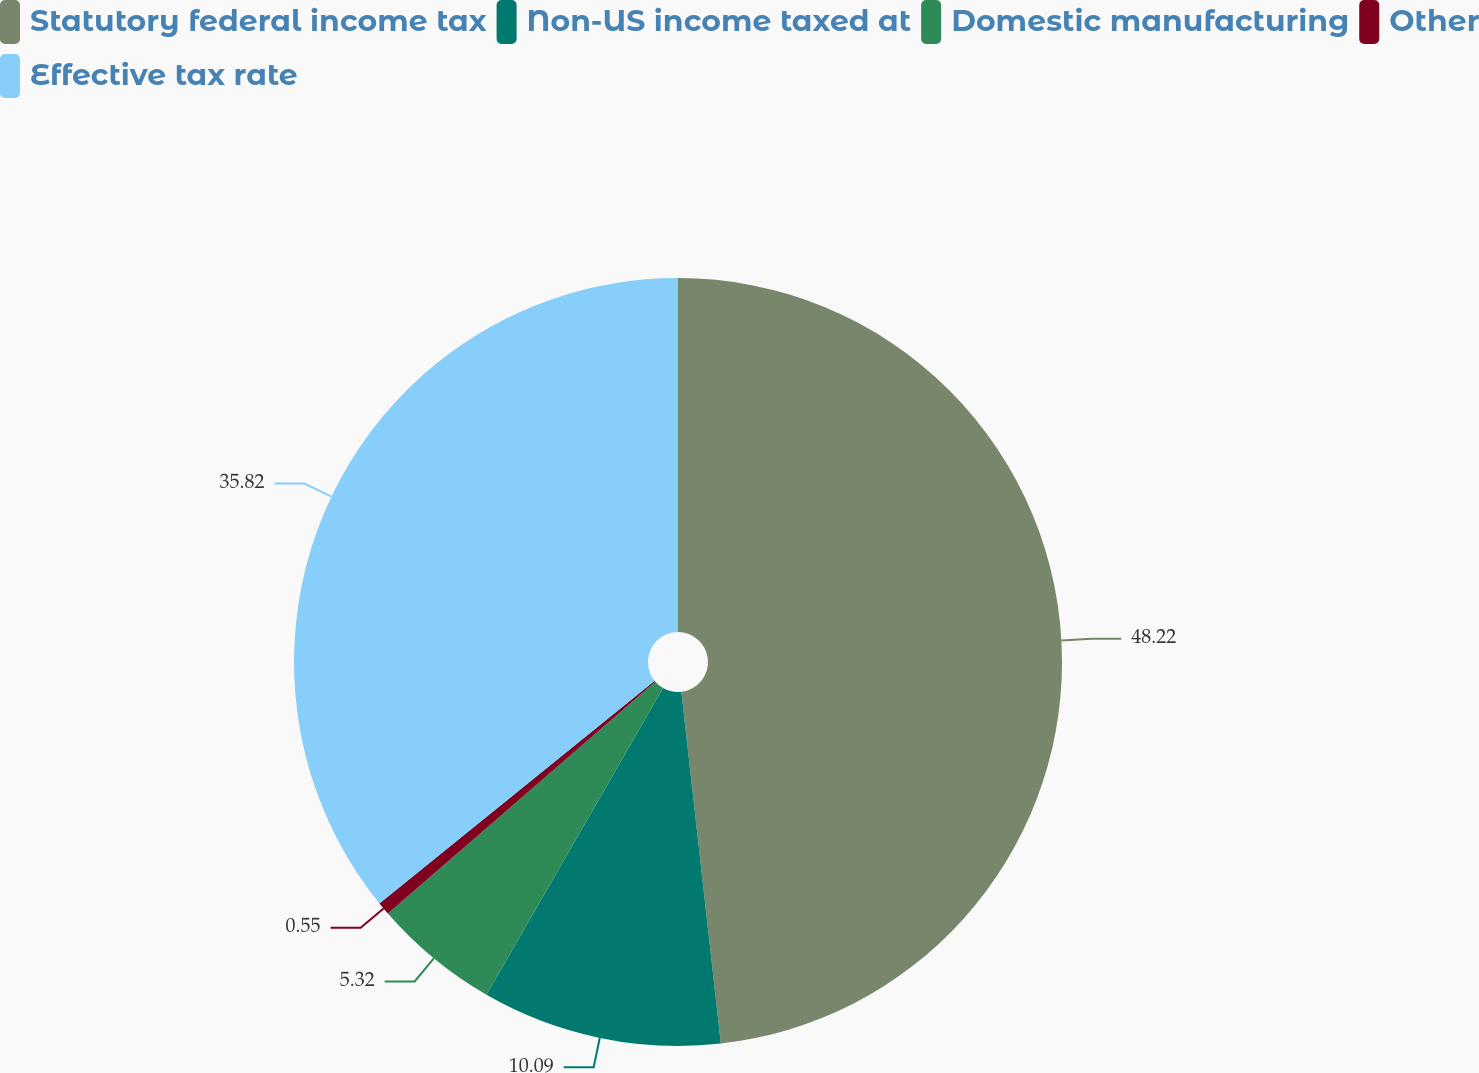Convert chart to OTSL. <chart><loc_0><loc_0><loc_500><loc_500><pie_chart><fcel>Statutory federal income tax<fcel>Non-US income taxed at<fcel>Domestic manufacturing<fcel>Other<fcel>Effective tax rate<nl><fcel>48.22%<fcel>10.09%<fcel>5.32%<fcel>0.55%<fcel>35.82%<nl></chart> 